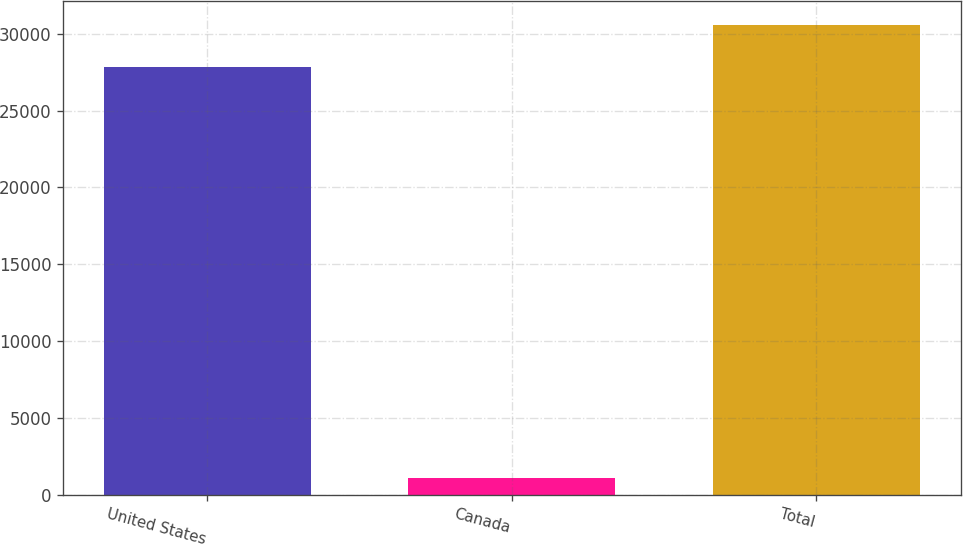Convert chart to OTSL. <chart><loc_0><loc_0><loc_500><loc_500><bar_chart><fcel>United States<fcel>Canada<fcel>Total<nl><fcel>27800<fcel>1118<fcel>30580<nl></chart> 